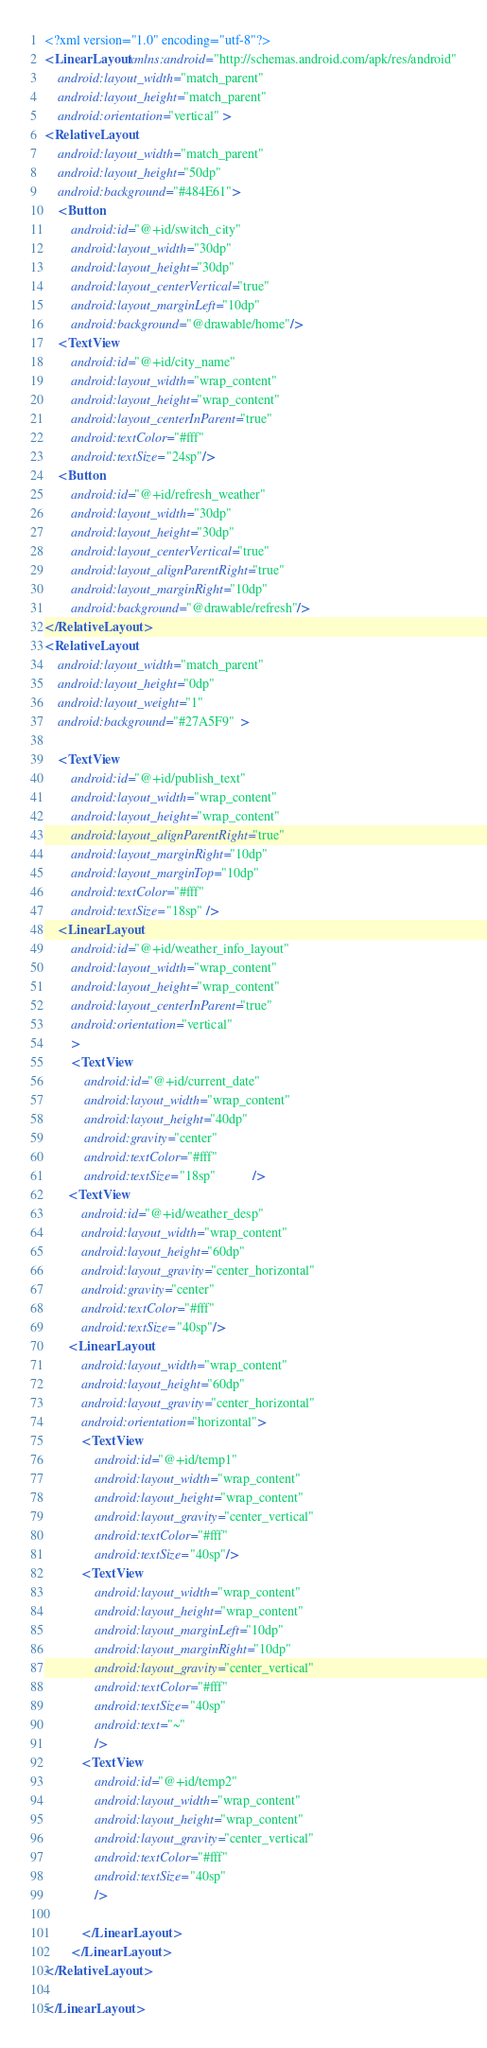Convert code to text. <code><loc_0><loc_0><loc_500><loc_500><_XML_><?xml version="1.0" encoding="utf-8"?>
<LinearLayout xmlns:android="http://schemas.android.com/apk/res/android"
    android:layout_width="match_parent"
    android:layout_height="match_parent"
    android:orientation="vertical" >
<RelativeLayout 
    android:layout_width="match_parent"
    android:layout_height="50dp"
    android:background="#484E61">
    <Button 
        android:id="@+id/switch_city"
        android:layout_width="30dp"
        android:layout_height="30dp"
        android:layout_centerVertical="true"
        android:layout_marginLeft="10dp"
        android:background="@drawable/home"/>
    <TextView 
        android:id="@+id/city_name"
        android:layout_width="wrap_content"
        android:layout_height="wrap_content"
        android:layout_centerInParent="true"
        android:textColor="#fff"
        android:textSize="24sp"/>
    <Button 
        android:id="@+id/refresh_weather"
        android:layout_width="30dp"
        android:layout_height="30dp"
        android:layout_centerVertical="true"
        android:layout_alignParentRight="true"
        android:layout_marginRight="10dp"
        android:background="@drawable/refresh"/>
</RelativeLayout>    
<RelativeLayout
    android:layout_width="match_parent"
    android:layout_height="0dp" 
    android:layout_weight="1" 
    android:background="#27A5F9"  >
    
    <TextView
        android:id="@+id/publish_text"
        android:layout_width="wrap_content"
        android:layout_height="wrap_content"
        android:layout_alignParentRight="true" 
        android:layout_marginRight="10dp"
        android:layout_marginTop="10dp"
        android:textColor="#fff"
        android:textSize="18sp" />
    <LinearLayout
        android:id="@+id/weather_info_layout"
        android:layout_width="wrap_content"
        android:layout_height="wrap_content"
        android:layout_centerInParent="true"
        android:orientation="vertical"        
        >
        <TextView 
            android:id="@+id/current_date"
            android:layout_width="wrap_content"
            android:layout_height="40dp"
            android:gravity="center" 
            android:textColor="#fff"
            android:textSize="18sp"           />
       <TextView 
           android:id="@+id/weather_desp"
           android:layout_width="wrap_content"
           android:layout_height="60dp"
           android:layout_gravity="center_horizontal"
           android:gravity="center"
           android:textColor="#fff"
           android:textSize="40sp"/>
       <LinearLayout
           android:layout_width="wrap_content"
           android:layout_height="60dp"
           android:layout_gravity="center_horizontal"
           android:orientation="horizontal">
           <TextView
               android:id="@+id/temp1"
               android:layout_width="wrap_content"
               android:layout_height="wrap_content"
               android:layout_gravity="center_vertical"
               android:textColor="#fff"
               android:textSize="40sp"/>
           <TextView 
               android:layout_width="wrap_content"
               android:layout_height="wrap_content"
               android:layout_marginLeft="10dp"
               android:layout_marginRight="10dp"
               android:layout_gravity="center_vertical"
               android:textColor="#fff"
               android:textSize="40sp"
               android:text="~"
               />
           <TextView
               android:id="@+id/temp2"
               android:layout_width="wrap_content"
               android:layout_height="wrap_content"
               android:layout_gravity="center_vertical"
               android:textColor="#fff"
               android:textSize="40sp"
               />
               
           </LinearLayout>
        </LinearLayout>
</RelativeLayout>

</LinearLayout>
</code> 